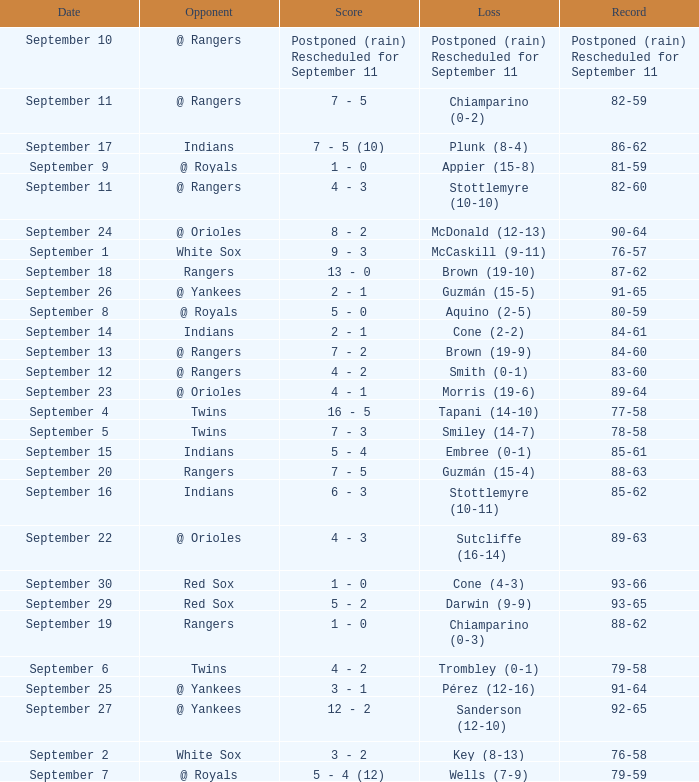What opponent has a record of 86-62? Indians. 